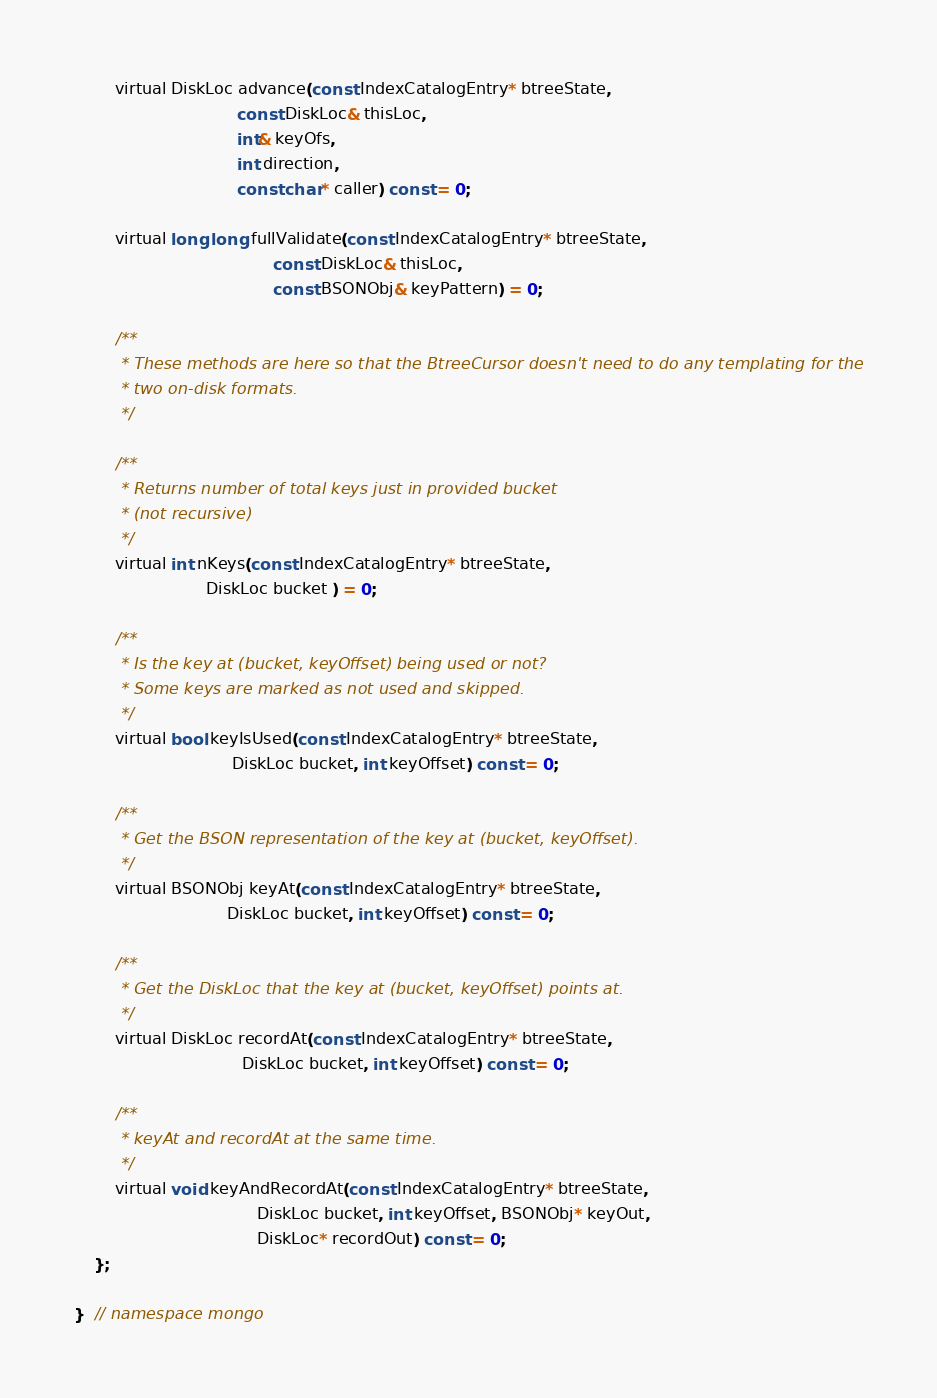<code> <loc_0><loc_0><loc_500><loc_500><_C_>        virtual DiskLoc advance(const IndexCatalogEntry* btreeState,
                                const DiskLoc& thisLoc,
                                int& keyOfs,
                                int direction,
                                const char* caller) const = 0;

        virtual long long fullValidate(const IndexCatalogEntry* btreeState,
                                       const DiskLoc& thisLoc,
                                       const BSONObj& keyPattern) = 0;

        /**
         * These methods are here so that the BtreeCursor doesn't need to do any templating for the
         * two on-disk formats.
         */

        /**
         * Returns number of total keys just in provided bucket
         * (not recursive)
         */
        virtual int nKeys(const IndexCatalogEntry* btreeState,
                          DiskLoc bucket ) = 0;

        /**
         * Is the key at (bucket, keyOffset) being used or not?
         * Some keys are marked as not used and skipped.
         */
        virtual bool keyIsUsed(const IndexCatalogEntry* btreeState,
                               DiskLoc bucket, int keyOffset) const = 0;

        /**
         * Get the BSON representation of the key at (bucket, keyOffset).
         */
        virtual BSONObj keyAt(const IndexCatalogEntry* btreeState,
                              DiskLoc bucket, int keyOffset) const = 0;

        /**
         * Get the DiskLoc that the key at (bucket, keyOffset) points at.
         */
        virtual DiskLoc recordAt(const IndexCatalogEntry* btreeState,
                                 DiskLoc bucket, int keyOffset) const = 0;

        /**
         * keyAt and recordAt at the same time.
         */
        virtual void keyAndRecordAt(const IndexCatalogEntry* btreeState,
                                    DiskLoc bucket, int keyOffset, BSONObj* keyOut,
                                    DiskLoc* recordOut) const = 0;
    };

}  // namespace mongo
</code> 